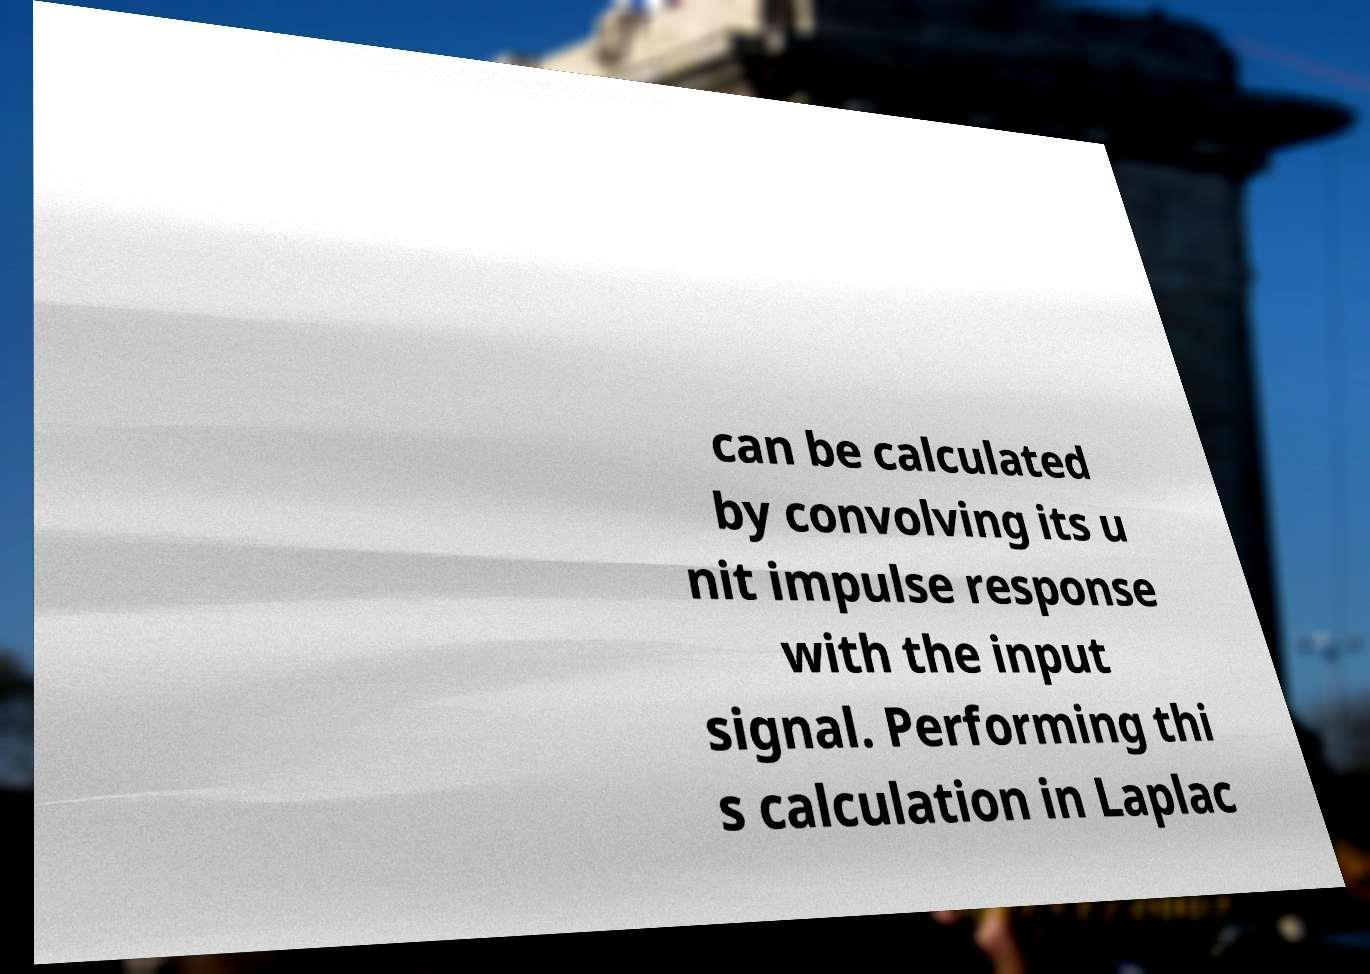Can you accurately transcribe the text from the provided image for me? can be calculated by convolving its u nit impulse response with the input signal. Performing thi s calculation in Laplac 